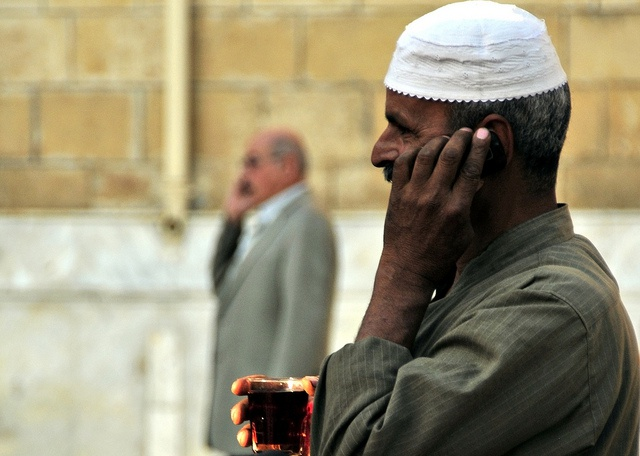Describe the objects in this image and their specific colors. I can see people in tan, black, gray, and lightgray tones, people in tan, gray, darkgray, and brown tones, cup in tan, black, maroon, khaki, and beige tones, cell phone in black and tan tones, and cell phone in tan, brown, and maroon tones in this image. 